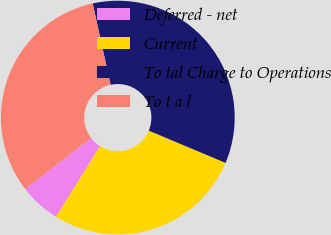Convert chart. <chart><loc_0><loc_0><loc_500><loc_500><pie_chart><fcel>Deferred - net<fcel>Current<fcel>To tal Charge to Operations<fcel>To t a l<nl><fcel>5.71%<fcel>27.52%<fcel>34.78%<fcel>31.99%<nl></chart> 